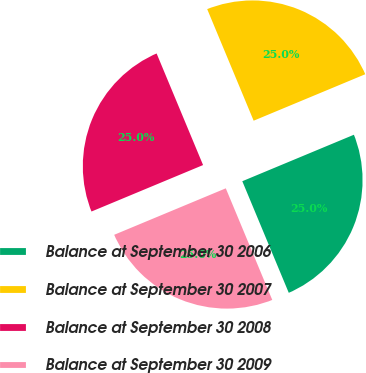Convert chart. <chart><loc_0><loc_0><loc_500><loc_500><pie_chart><fcel>Balance at September 30 2006<fcel>Balance at September 30 2007<fcel>Balance at September 30 2008<fcel>Balance at September 30 2009<nl><fcel>25.0%<fcel>25.0%<fcel>25.0%<fcel>25.0%<nl></chart> 